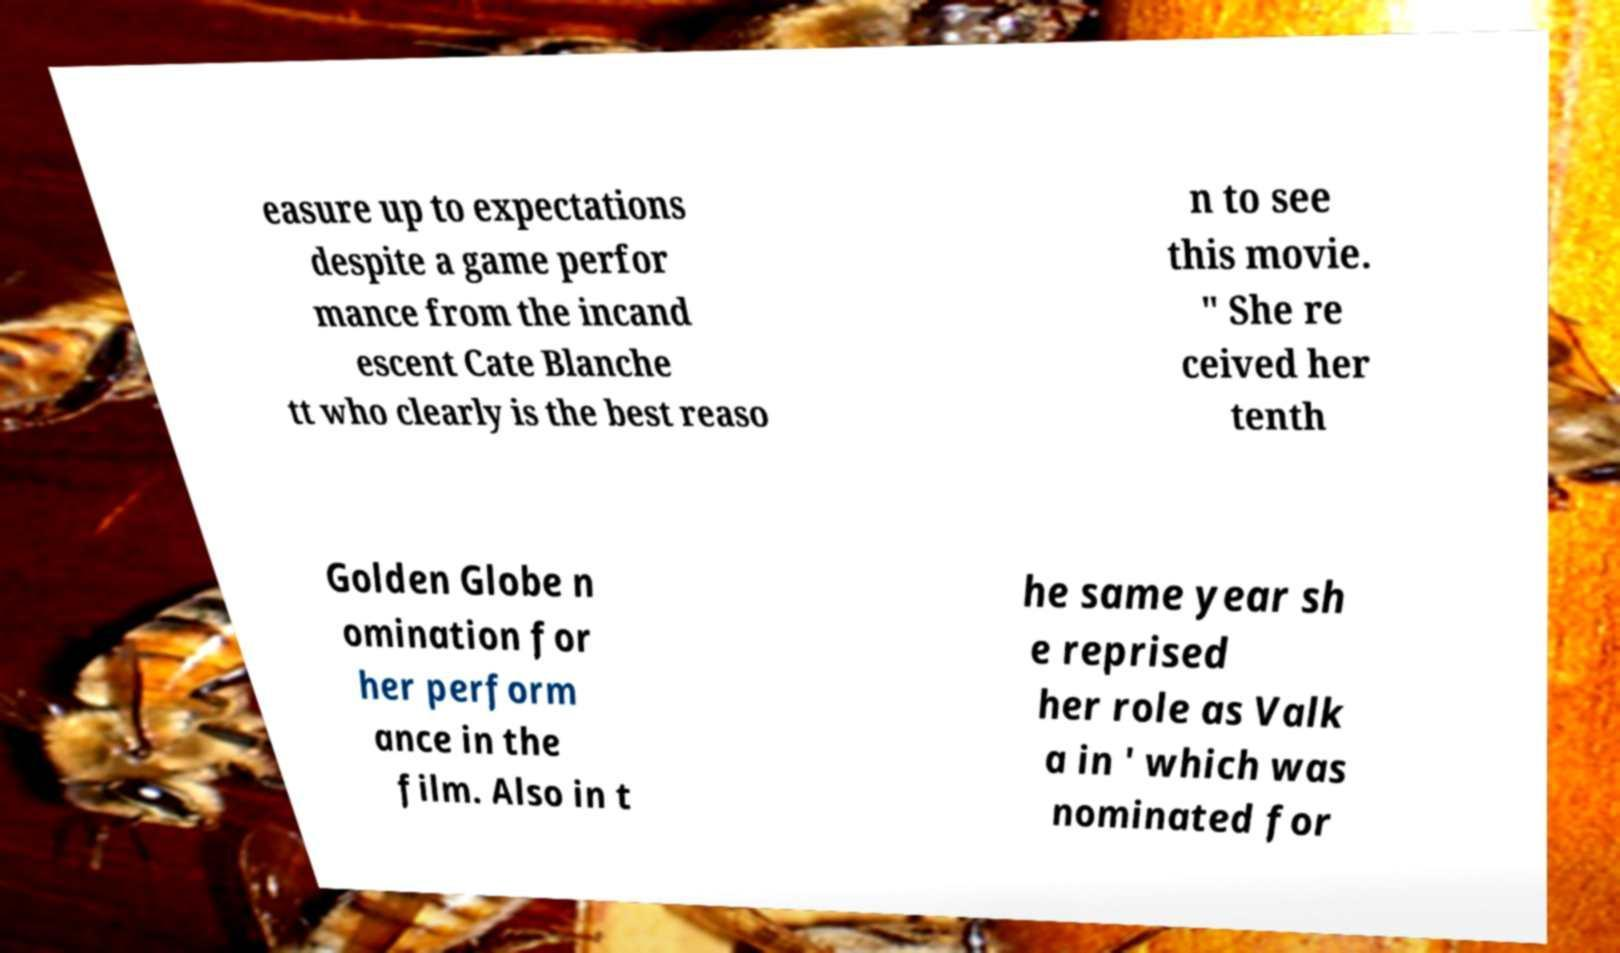Could you extract and type out the text from this image? easure up to expectations despite a game perfor mance from the incand escent Cate Blanche tt who clearly is the best reaso n to see this movie. " She re ceived her tenth Golden Globe n omination for her perform ance in the film. Also in t he same year sh e reprised her role as Valk a in ' which was nominated for 